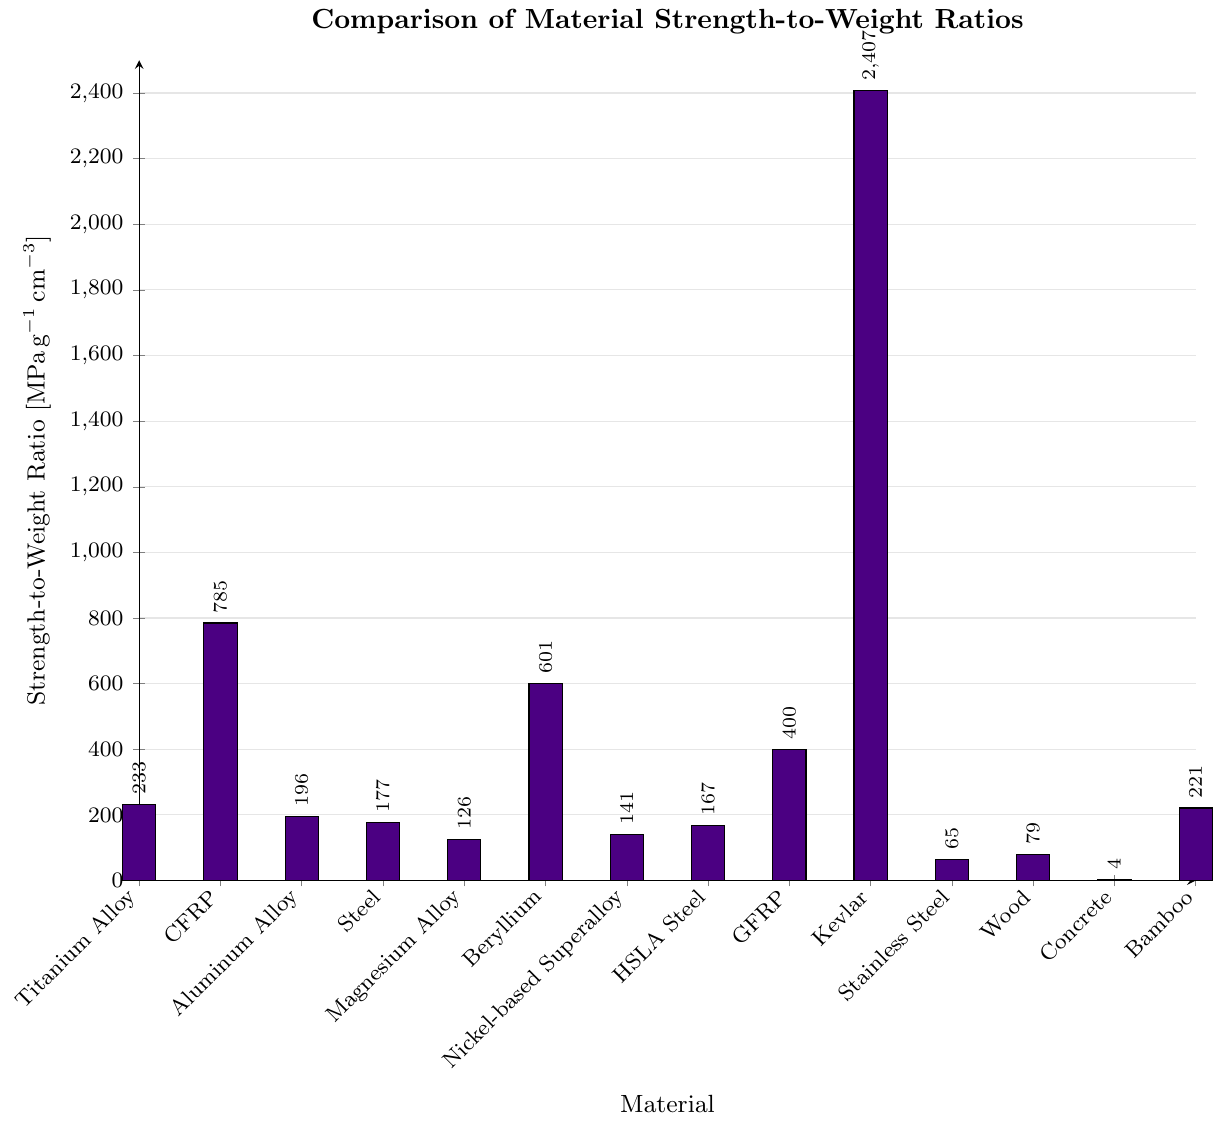What material has the highest strength-to-weight ratio? To identify the material with the highest strength-to-weight ratio, examine the tallest bar in the bar chart, which represents the material with the highest value.
Answer: Kevlar Which material has a lower strength-to-weight ratio, Stainless Steel (304) or Concrete? By comparing the heights of the bars representing Stainless Steel (304) and Concrete, the shorter bar indicates the material with a lower strength-to-weight ratio.
Answer: Concrete How does the strength-to-weight ratio of CFRP compare to that of GFRP? Compare the heights of the bars representing CFRP and GFRP. CFRP has a taller bar than GFRP, indicating a higher strength-to-weight ratio.
Answer: CFRP is higher What is the difference in strength-to-weight ratio between Beryllium and Magnesium Alloy (AZ31B)? Subtract the strength-to-weight ratio of Magnesium Alloy (126) from that of Beryllium (601). \(601 - 126 = 475\)
Answer: 475 What is the average strength-to-weight ratio of Titanium Alloy, Aluminum Alloy, and Steel? Sum the strength-to-weight ratios of Titanium Alloy (233), Aluminum Alloy (196), and Steel (177) and divide by 3. \( \frac{233 + 196 + 177}{3} = 202 \)
Answer: 202 Which material has a higher strength-to-weight ratio: Beryllium or Nickel-based Superalloy (Inconel 718)? Compare the heights of the bars representing Beryllium and the Nickel-based Superalloy. Beryllium has a taller bar, indicating a higher strength-to-weight ratio.
Answer: Beryllium How much greater is Kevlar’s strength-to-weight ratio compared to Bamboo? Subtract the strength-to-weight ratio of Bamboo (221) from that of Kevlar (2407). \(2407 - 221 = 2186\)
Answer: 2186 Determine if Glass Fiber Reinforced Polymer's (GFRP) strength-to-weight ratio is equal to the sum of Concrete's and Wood's. Sum the strength-to-weight ratios of Concrete (4) and Wood (79). Compare this sum to GFRP’s value (400). \(4 + 79 = 83 \neq 400\)
Answer: No What is the median strength-to-weight ratio of the listed materials? Arrange the strength-to-weight ratios in ascending order: 4, 65, 79, 126, 141, 167, 177, 196, 221, 233, 400, 601, 785, 2407. With 14 values, the median is the average of the 7th and 8th values: (177 + 196) / 2 = 186.5
Answer: 186.5 Identify the two materials with the smallest difference in their strength-to-weight ratios. Examine the bar heights and find the materials that are closest to each other in value. Steel (177) and HSLA Steel (167) have a difference of \(177 - 167 = 10\).
Answer: Steel and HSLA Steel 